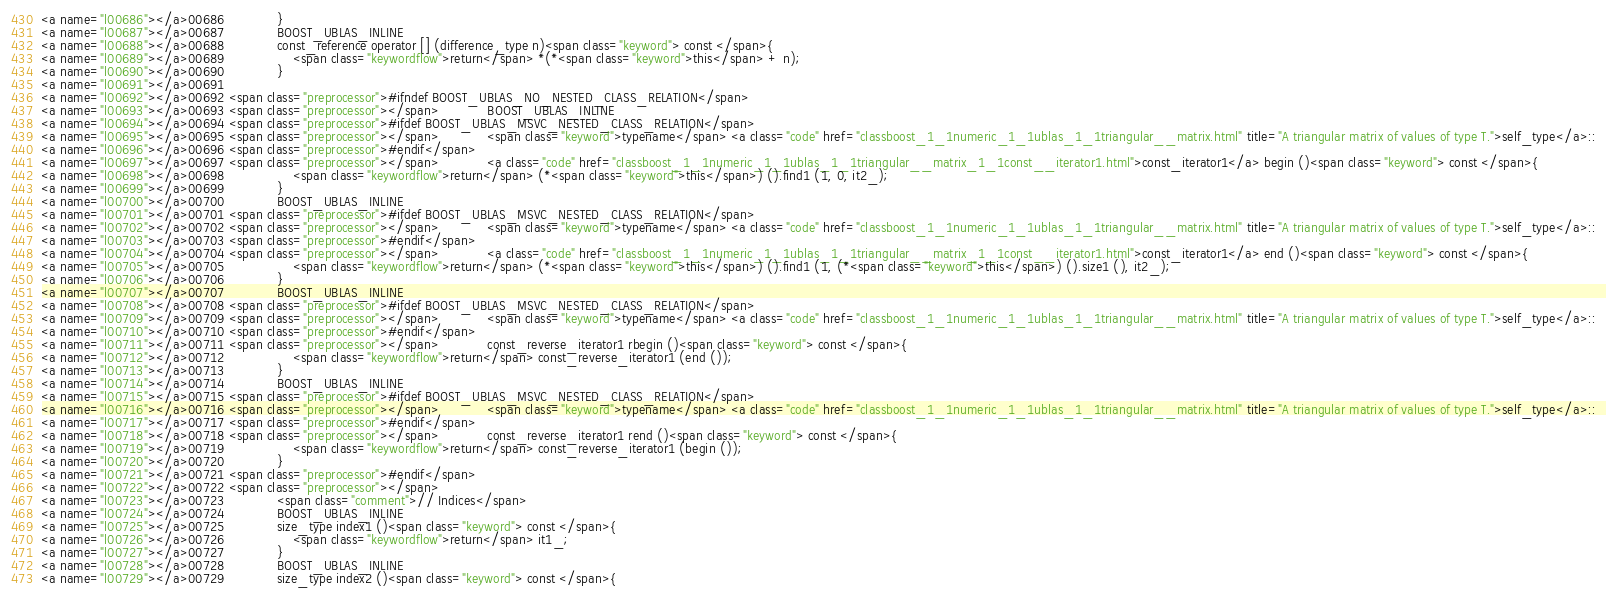Convert code to text. <code><loc_0><loc_0><loc_500><loc_500><_HTML_><a name="l00686"></a>00686             }
<a name="l00687"></a>00687             BOOST_UBLAS_INLINE
<a name="l00688"></a>00688             const_reference operator [] (difference_type n)<span class="keyword"> const </span>{
<a name="l00689"></a>00689                 <span class="keywordflow">return</span> *(*<span class="keyword">this</span> + n);
<a name="l00690"></a>00690             }
<a name="l00691"></a>00691 
<a name="l00692"></a>00692 <span class="preprocessor">#ifndef BOOST_UBLAS_NO_NESTED_CLASS_RELATION</span>
<a name="l00693"></a>00693 <span class="preprocessor"></span>            BOOST_UBLAS_INLINE
<a name="l00694"></a>00694 <span class="preprocessor">#ifdef BOOST_UBLAS_MSVC_NESTED_CLASS_RELATION</span>
<a name="l00695"></a>00695 <span class="preprocessor"></span>            <span class="keyword">typename</span> <a class="code" href="classboost_1_1numeric_1_1ublas_1_1triangular__matrix.html" title="A triangular matrix of values of type T.">self_type</a>::
<a name="l00696"></a>00696 <span class="preprocessor">#endif</span>
<a name="l00697"></a>00697 <span class="preprocessor"></span>            <a class="code" href="classboost_1_1numeric_1_1ublas_1_1triangular__matrix_1_1const__iterator1.html">const_iterator1</a> begin ()<span class="keyword"> const </span>{
<a name="l00698"></a>00698                 <span class="keywordflow">return</span> (*<span class="keyword">this</span>) ().find1 (1, 0, it2_);
<a name="l00699"></a>00699             }
<a name="l00700"></a>00700             BOOST_UBLAS_INLINE
<a name="l00701"></a>00701 <span class="preprocessor">#ifdef BOOST_UBLAS_MSVC_NESTED_CLASS_RELATION</span>
<a name="l00702"></a>00702 <span class="preprocessor"></span>            <span class="keyword">typename</span> <a class="code" href="classboost_1_1numeric_1_1ublas_1_1triangular__matrix.html" title="A triangular matrix of values of type T.">self_type</a>::
<a name="l00703"></a>00703 <span class="preprocessor">#endif</span>
<a name="l00704"></a>00704 <span class="preprocessor"></span>            <a class="code" href="classboost_1_1numeric_1_1ublas_1_1triangular__matrix_1_1const__iterator1.html">const_iterator1</a> end ()<span class="keyword"> const </span>{
<a name="l00705"></a>00705                 <span class="keywordflow">return</span> (*<span class="keyword">this</span>) ().find1 (1, (*<span class="keyword">this</span>) ().size1 (), it2_);
<a name="l00706"></a>00706             }
<a name="l00707"></a>00707             BOOST_UBLAS_INLINE
<a name="l00708"></a>00708 <span class="preprocessor">#ifdef BOOST_UBLAS_MSVC_NESTED_CLASS_RELATION</span>
<a name="l00709"></a>00709 <span class="preprocessor"></span>            <span class="keyword">typename</span> <a class="code" href="classboost_1_1numeric_1_1ublas_1_1triangular__matrix.html" title="A triangular matrix of values of type T.">self_type</a>::
<a name="l00710"></a>00710 <span class="preprocessor">#endif</span>
<a name="l00711"></a>00711 <span class="preprocessor"></span>            const_reverse_iterator1 rbegin ()<span class="keyword"> const </span>{
<a name="l00712"></a>00712                 <span class="keywordflow">return</span> const_reverse_iterator1 (end ());
<a name="l00713"></a>00713             }
<a name="l00714"></a>00714             BOOST_UBLAS_INLINE
<a name="l00715"></a>00715 <span class="preprocessor">#ifdef BOOST_UBLAS_MSVC_NESTED_CLASS_RELATION</span>
<a name="l00716"></a>00716 <span class="preprocessor"></span>            <span class="keyword">typename</span> <a class="code" href="classboost_1_1numeric_1_1ublas_1_1triangular__matrix.html" title="A triangular matrix of values of type T.">self_type</a>::
<a name="l00717"></a>00717 <span class="preprocessor">#endif</span>
<a name="l00718"></a>00718 <span class="preprocessor"></span>            const_reverse_iterator1 rend ()<span class="keyword"> const </span>{
<a name="l00719"></a>00719                 <span class="keywordflow">return</span> const_reverse_iterator1 (begin ());
<a name="l00720"></a>00720             }
<a name="l00721"></a>00721 <span class="preprocessor">#endif</span>
<a name="l00722"></a>00722 <span class="preprocessor"></span>
<a name="l00723"></a>00723             <span class="comment">// Indices</span>
<a name="l00724"></a>00724             BOOST_UBLAS_INLINE
<a name="l00725"></a>00725             size_type index1 ()<span class="keyword"> const </span>{
<a name="l00726"></a>00726                 <span class="keywordflow">return</span> it1_;
<a name="l00727"></a>00727             }
<a name="l00728"></a>00728             BOOST_UBLAS_INLINE
<a name="l00729"></a>00729             size_type index2 ()<span class="keyword"> const </span>{</code> 